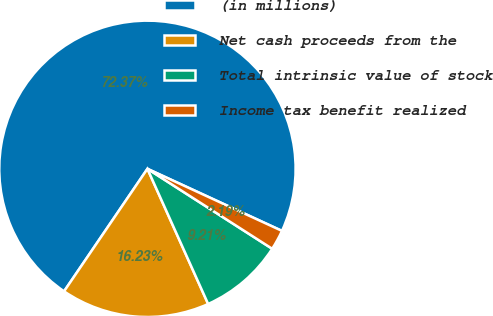Convert chart. <chart><loc_0><loc_0><loc_500><loc_500><pie_chart><fcel>(in millions)<fcel>Net cash proceeds from the<fcel>Total intrinsic value of stock<fcel>Income tax benefit realized<nl><fcel>72.37%<fcel>16.23%<fcel>9.21%<fcel>2.19%<nl></chart> 